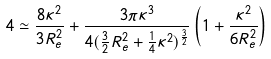<formula> <loc_0><loc_0><loc_500><loc_500>4 \simeq \frac { 8 \kappa ^ { 2 } } { 3 R ^ { 2 } _ { e } } + \frac { 3 \pi \kappa ^ { 3 } } { 4 ( \frac { 3 } { 2 } R ^ { 2 } _ { e } + \frac { 1 } { 4 } \kappa ^ { 2 } ) ^ { \frac { 3 } { 2 } } } \left ( 1 + \frac { \kappa ^ { 2 } } { 6 R ^ { 2 } _ { e } } \right )</formula> 